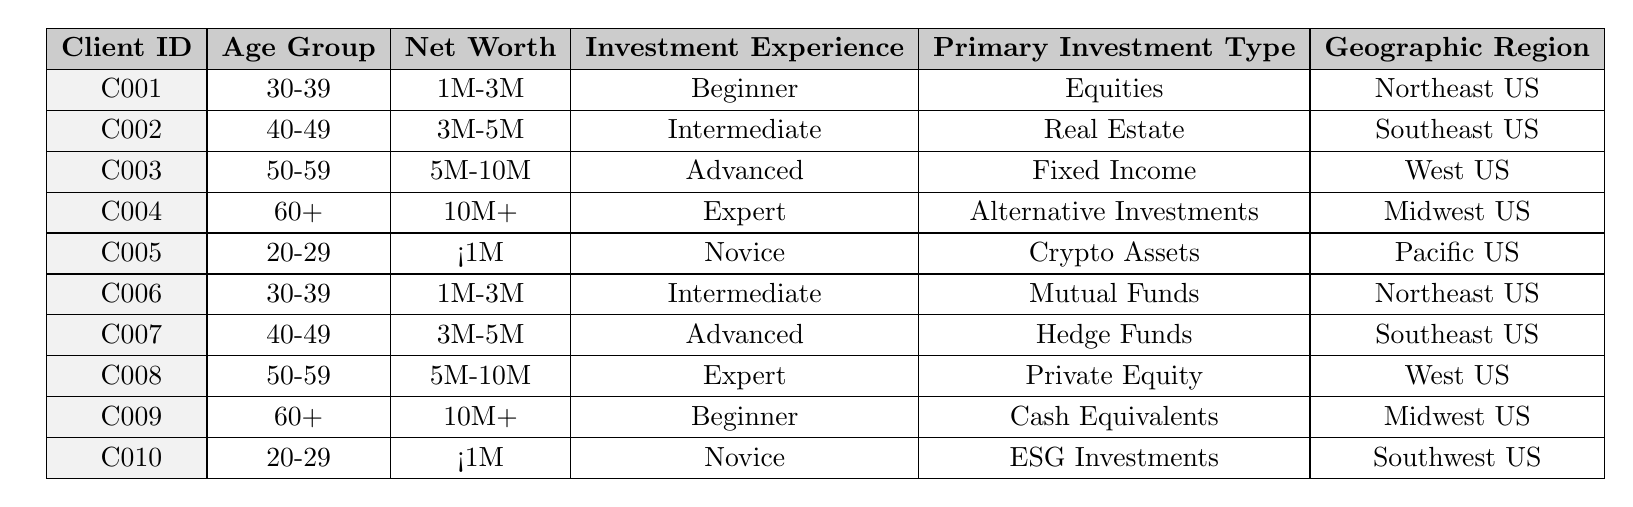What is the age group of Client C003? Looking at the table, the entry for Client C003 shows the age group as "50-59".
Answer: 50-59 How many clients have a net worth of less than 1 million? There are two clients (C005 and C010) with a net worth listed as "<1M" in the table.
Answer: 2 clients Which primary investment type is most common among clients aged 40-49? For clients in the age group "40-49", the primary investment types are "Real Estate" (C002) and "Hedge Funds" (C007). Since both are unique, there is no most common type.
Answer: No most common type Do any clients have both advanced investment experience and a net worth of 5 million or more? Yes, both Client C003 and C008 have 'Advanced' investment experience, with C003 having a net worth of "5M-10M" and C008 "5M-10M".
Answer: Yes What is the average net worth of clients aged 60 and above? There are two clients aged 60 or older: C004 with a net worth of "10M+" and C009 with "<1M". Converting these values estimates 10M as 10 million and <1M as less than 1 million for calculations. The average is (10M + 0.5M) / 2 = 5.25M.
Answer: 5.25 million What percentage of clients have a primary investment type of real estate? There are 10 clients total, and only Client C002 has real estate as the primary investment type. So, the percentage is (1/10) * 100 = 10%.
Answer: 10% Which geographic region has the highest representation in the table? The Northeast US has 2 clients (C001 and C006), the Southeast US has 2 clients (C002 and C007), the West US has 2 clients (C003 and C008), the Midwest US has 2 clients (C004 and C009), and the Pacific and Southwest US have 1 each (C005 and C010). Thus, there is no region with the highest representation.
Answer: No region with highest representation How many clients in the 30-39 age group have advanced investment experience? Only Client C001 and C006 fall in the 30-39 age group and their investment experiences are "Beginner" and "Intermediate" respectively. Therefore, there are no clients.
Answer: 0 clients Is there any client with less than one million net worth who has expert investment experience? Checking the table, Clients C005 and C010 have less than one million net worth, but both have "Novice" as their investment experience, thus there are no such clients.
Answer: No What is the most represented net worth category among all clients? The net worth categories are as follows: "<1M" (2 clients), "1M-3M" (2 clients), "3M-5M" (2 clients), "5M-10M" (2 clients), "10M+" (2 clients). All categories are equally represented with 2 clients each.
Answer: None is most represented 